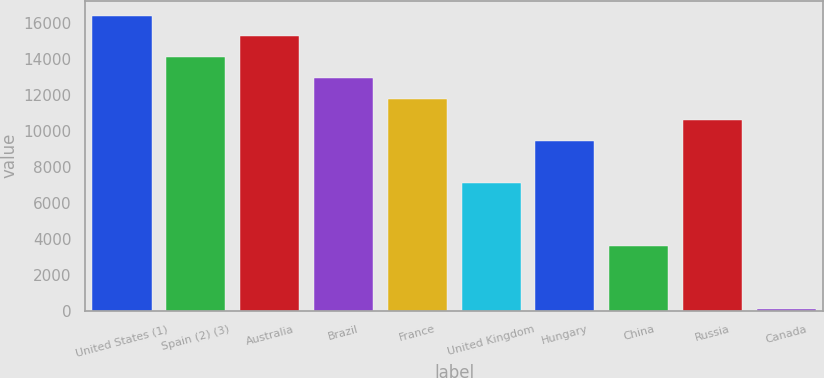Convert chart. <chart><loc_0><loc_0><loc_500><loc_500><bar_chart><fcel>United States (1)<fcel>Spain (2) (3)<fcel>Australia<fcel>Brazil<fcel>France<fcel>United Kingdom<fcel>Hungary<fcel>China<fcel>Russia<fcel>Canada<nl><fcel>16423.2<fcel>14094.6<fcel>15258.9<fcel>12930.3<fcel>11766<fcel>7108.8<fcel>9437.4<fcel>3615.9<fcel>10601.7<fcel>123<nl></chart> 